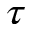Convert formula to latex. <formula><loc_0><loc_0><loc_500><loc_500>\tau</formula> 